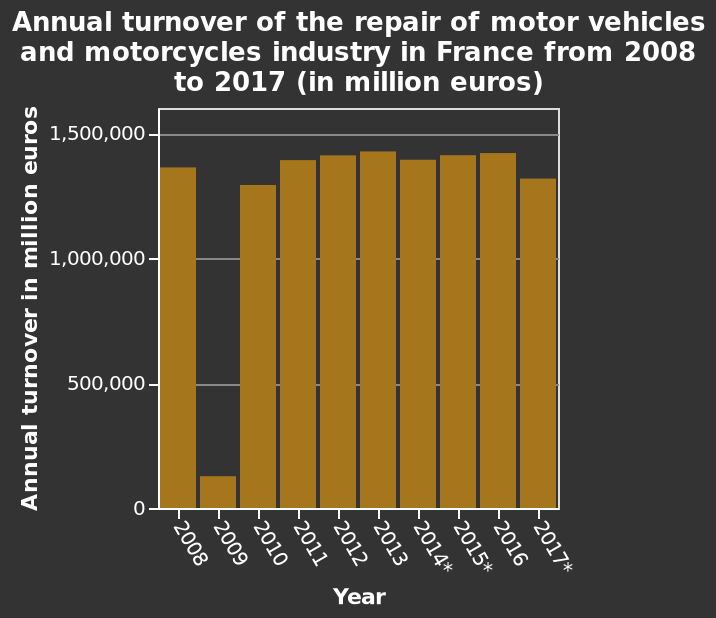<image>
please summary the statistics and relations of the chart On average, the graph shows the annual turnover has been between 1,300,000 and 1,400,000 million euros for the years 2008 to 2017, with the exception of 2009 where the figure dropped significantly to around 100,000 million euros. In 2010 it had recovered to around 1,300,000 million euros which was still the lowest year after 2009 but was followed by several years of gradually rising figures until it once again dropped to around 1,300,000, just slightly above 2010 figures. Besides 2009, were there any other years with an annual turnover below 250,000? No, all the other years from 2008 to 2017 had annual turnovers of more than 1,000,000. What does the x-axis represent? The x-axis represents the years from 2008 to 2017. What does the y-axis measure? The y-axis measures the annual turnover in million euros. please describe the details of the chart Here a bar chart is titled Annual turnover of the repair of motor vehicles and motorcycles industry in France from 2008 to 2017 (in million euros). The x-axis shows Year while the y-axis measures Annual turnover in million euros. What is the title of the bar chart? The title of the bar chart is "Annual turnover of the repair of motor vehicles and motorcycles industry in France from 2008 to 2017 (in million euros)." What is the range of years depicted in the bar chart? The bar chart depicts the annual turnover of the industry from 2008 to 2017. How many years in total were considered in the analysis of annual turnover for motorcycle repair in France? A total of 10 years, from 2008 to 2017, were considered in the analysis of annual turnover for motorcycle repair in France. 